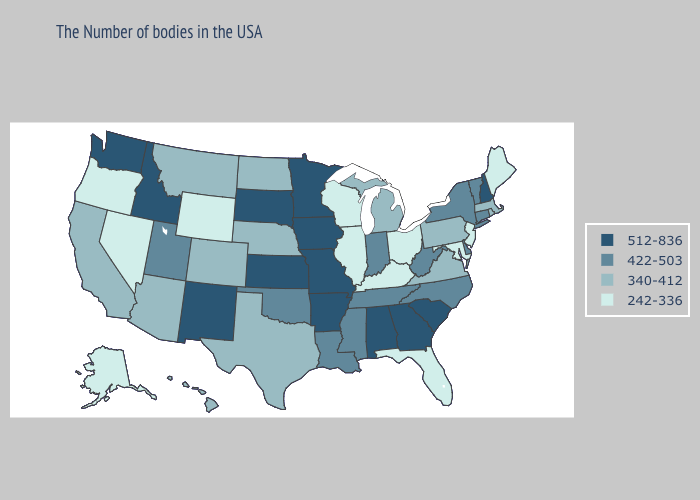Does Nevada have the highest value in the West?
Write a very short answer. No. What is the lowest value in the USA?
Answer briefly. 242-336. What is the lowest value in states that border Kansas?
Give a very brief answer. 340-412. What is the value of North Carolina?
Concise answer only. 422-503. Is the legend a continuous bar?
Be succinct. No. Which states hav the highest value in the West?
Short answer required. New Mexico, Idaho, Washington. Name the states that have a value in the range 512-836?
Keep it brief. New Hampshire, South Carolina, Georgia, Alabama, Missouri, Arkansas, Minnesota, Iowa, Kansas, South Dakota, New Mexico, Idaho, Washington. Which states have the lowest value in the MidWest?
Concise answer only. Ohio, Wisconsin, Illinois. Does Washington have the highest value in the West?
Short answer required. Yes. What is the value of Nebraska?
Keep it brief. 340-412. Does Maine have the lowest value in the USA?
Concise answer only. Yes. Name the states that have a value in the range 512-836?
Be succinct. New Hampshire, South Carolina, Georgia, Alabama, Missouri, Arkansas, Minnesota, Iowa, Kansas, South Dakota, New Mexico, Idaho, Washington. Name the states that have a value in the range 422-503?
Concise answer only. Vermont, Connecticut, New York, Delaware, North Carolina, West Virginia, Indiana, Tennessee, Mississippi, Louisiana, Oklahoma, Utah. How many symbols are there in the legend?
Quick response, please. 4. How many symbols are there in the legend?
Concise answer only. 4. 